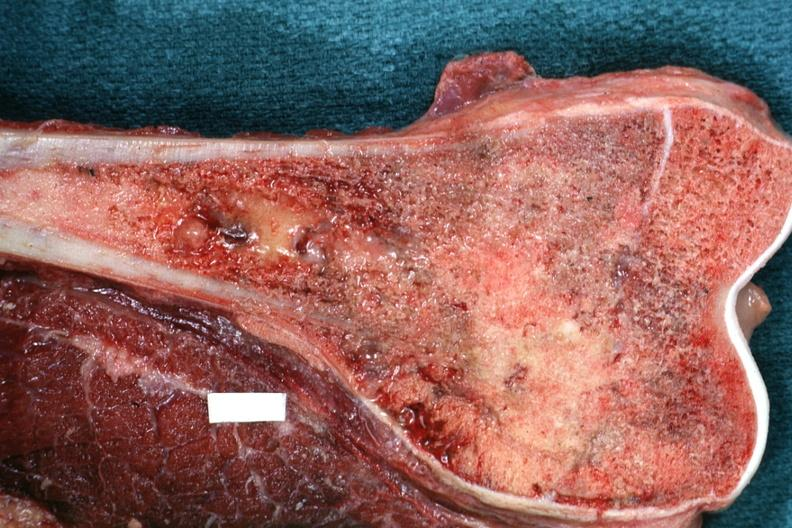what does this image show?
Answer the question using a single word or phrase. Sectioned femur lesion is distal end excellent example 